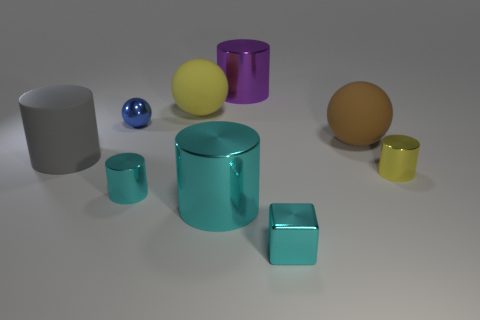Subtract all yellow cylinders. How many cylinders are left? 4 Subtract all big purple metal cylinders. How many cylinders are left? 4 Subtract all brown cylinders. Subtract all red blocks. How many cylinders are left? 5 Add 1 small cyan cubes. How many objects exist? 10 Subtract all cubes. How many objects are left? 8 Subtract all large purple metallic things. Subtract all balls. How many objects are left? 5 Add 4 big cyan cylinders. How many big cyan cylinders are left? 5 Add 1 big brown metal spheres. How many big brown metal spheres exist? 1 Subtract 0 green spheres. How many objects are left? 9 